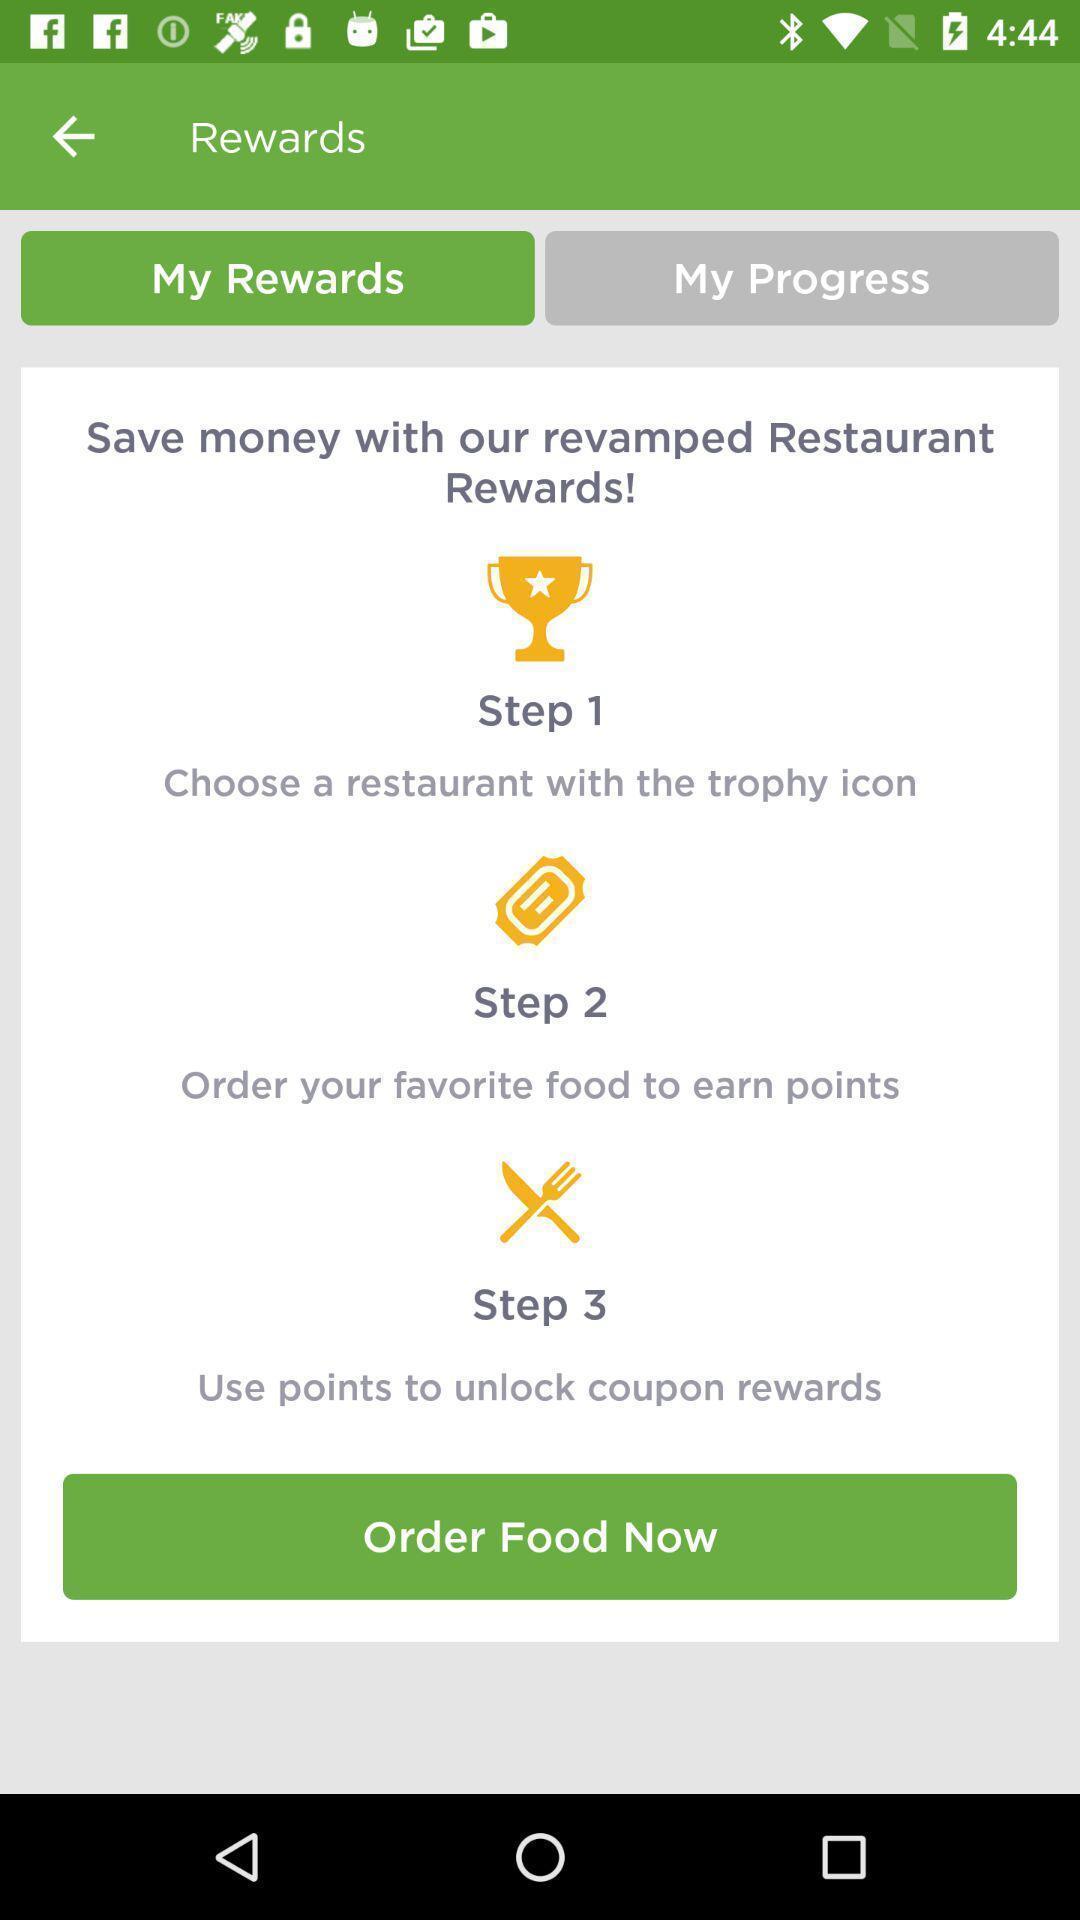Provide a detailed account of this screenshot. Page showing steps for getting rewards. 